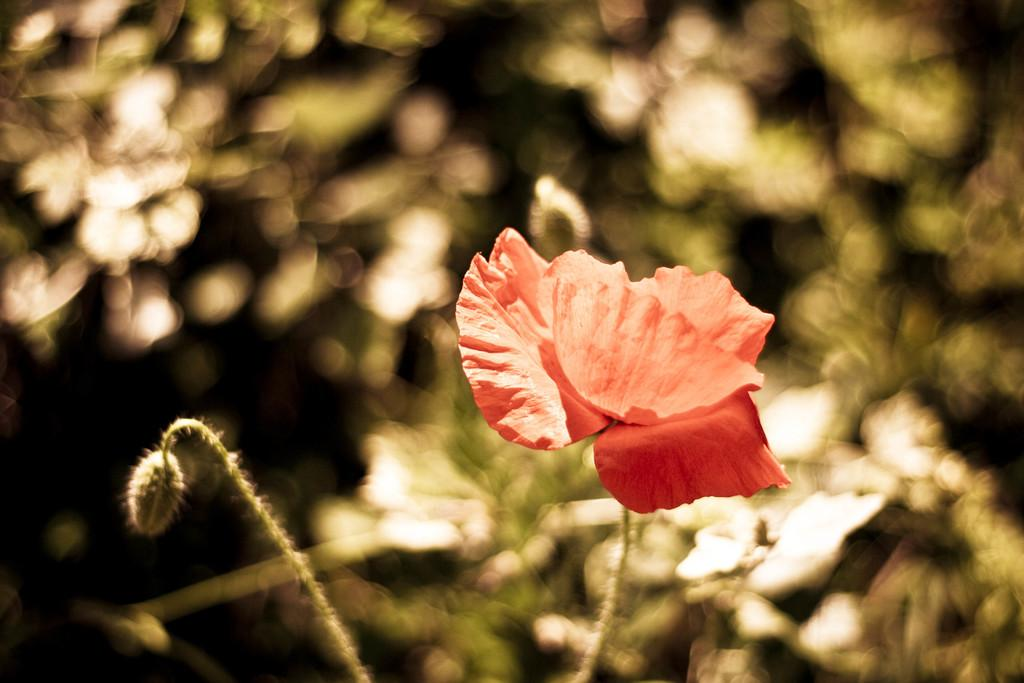What type of flower is present in the image? There is a red color flower in the image. Can you describe the stage of the adjacent flower? There is a bud beside the flower. What type of vegetation can be seen in the image? Trees are visible in the image. Is there any area in the image that appears out of focus? Yes, there is a blurry area in the image. What type of stew is being prepared in the image? There is no stew present in the image; it features a red color flower, a bud, trees, and a blurry area. Can you see any birds in the image? There are no birds visible in the image. 